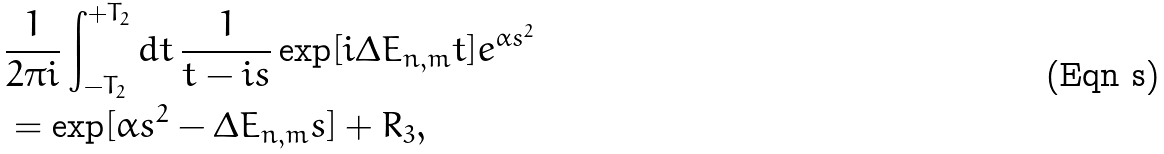<formula> <loc_0><loc_0><loc_500><loc_500>& \frac { 1 } { 2 \pi i } \int _ { - T _ { 2 } } ^ { + T _ { 2 } } d t \, \frac { 1 } { t - i s } \exp [ i \Delta E _ { n , m } t ] e ^ { \alpha s ^ { 2 } } \\ & = \exp [ \alpha s ^ { 2 } - \Delta E _ { n , m } s ] + R _ { 3 } ,</formula> 